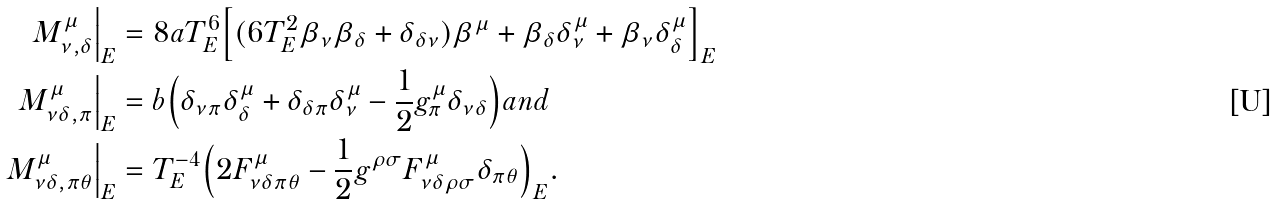<formula> <loc_0><loc_0><loc_500><loc_500>M ^ { \mu } _ { \nu , \delta } \Big | _ { E } & = 8 a T _ { E } ^ { 6 } \Big [ ( 6 T _ { E } ^ { 2 } \beta _ { \nu } \beta _ { \delta } + \delta _ { \delta \nu } ) \beta ^ { \mu } + \beta _ { \delta } \delta ^ { \mu } _ { \nu } + \beta _ { \nu } \delta ^ { \mu } _ { \delta } \Big ] _ { E } \\ M ^ { \mu } _ { \nu \delta , \pi } \Big | _ { E } & = b \Big ( \delta _ { \nu \pi } \delta ^ { \mu } _ { \delta } + \delta _ { \delta \pi } \delta ^ { \mu } _ { \nu } - \frac { 1 } { 2 } g ^ { \mu } _ { \pi } \delta _ { \nu \delta } \Big ) a n d \\ M ^ { \mu } _ { \nu \delta , \pi \theta } \Big | _ { E } & = T _ { E } ^ { - 4 } \Big ( 2 F ^ { \mu } _ { \nu \delta \pi \theta } - \frac { 1 } { 2 } g ^ { \rho \sigma } F ^ { \mu } _ { \nu \delta \rho \sigma } \delta _ { \pi \theta } \Big ) _ { E } .</formula> 